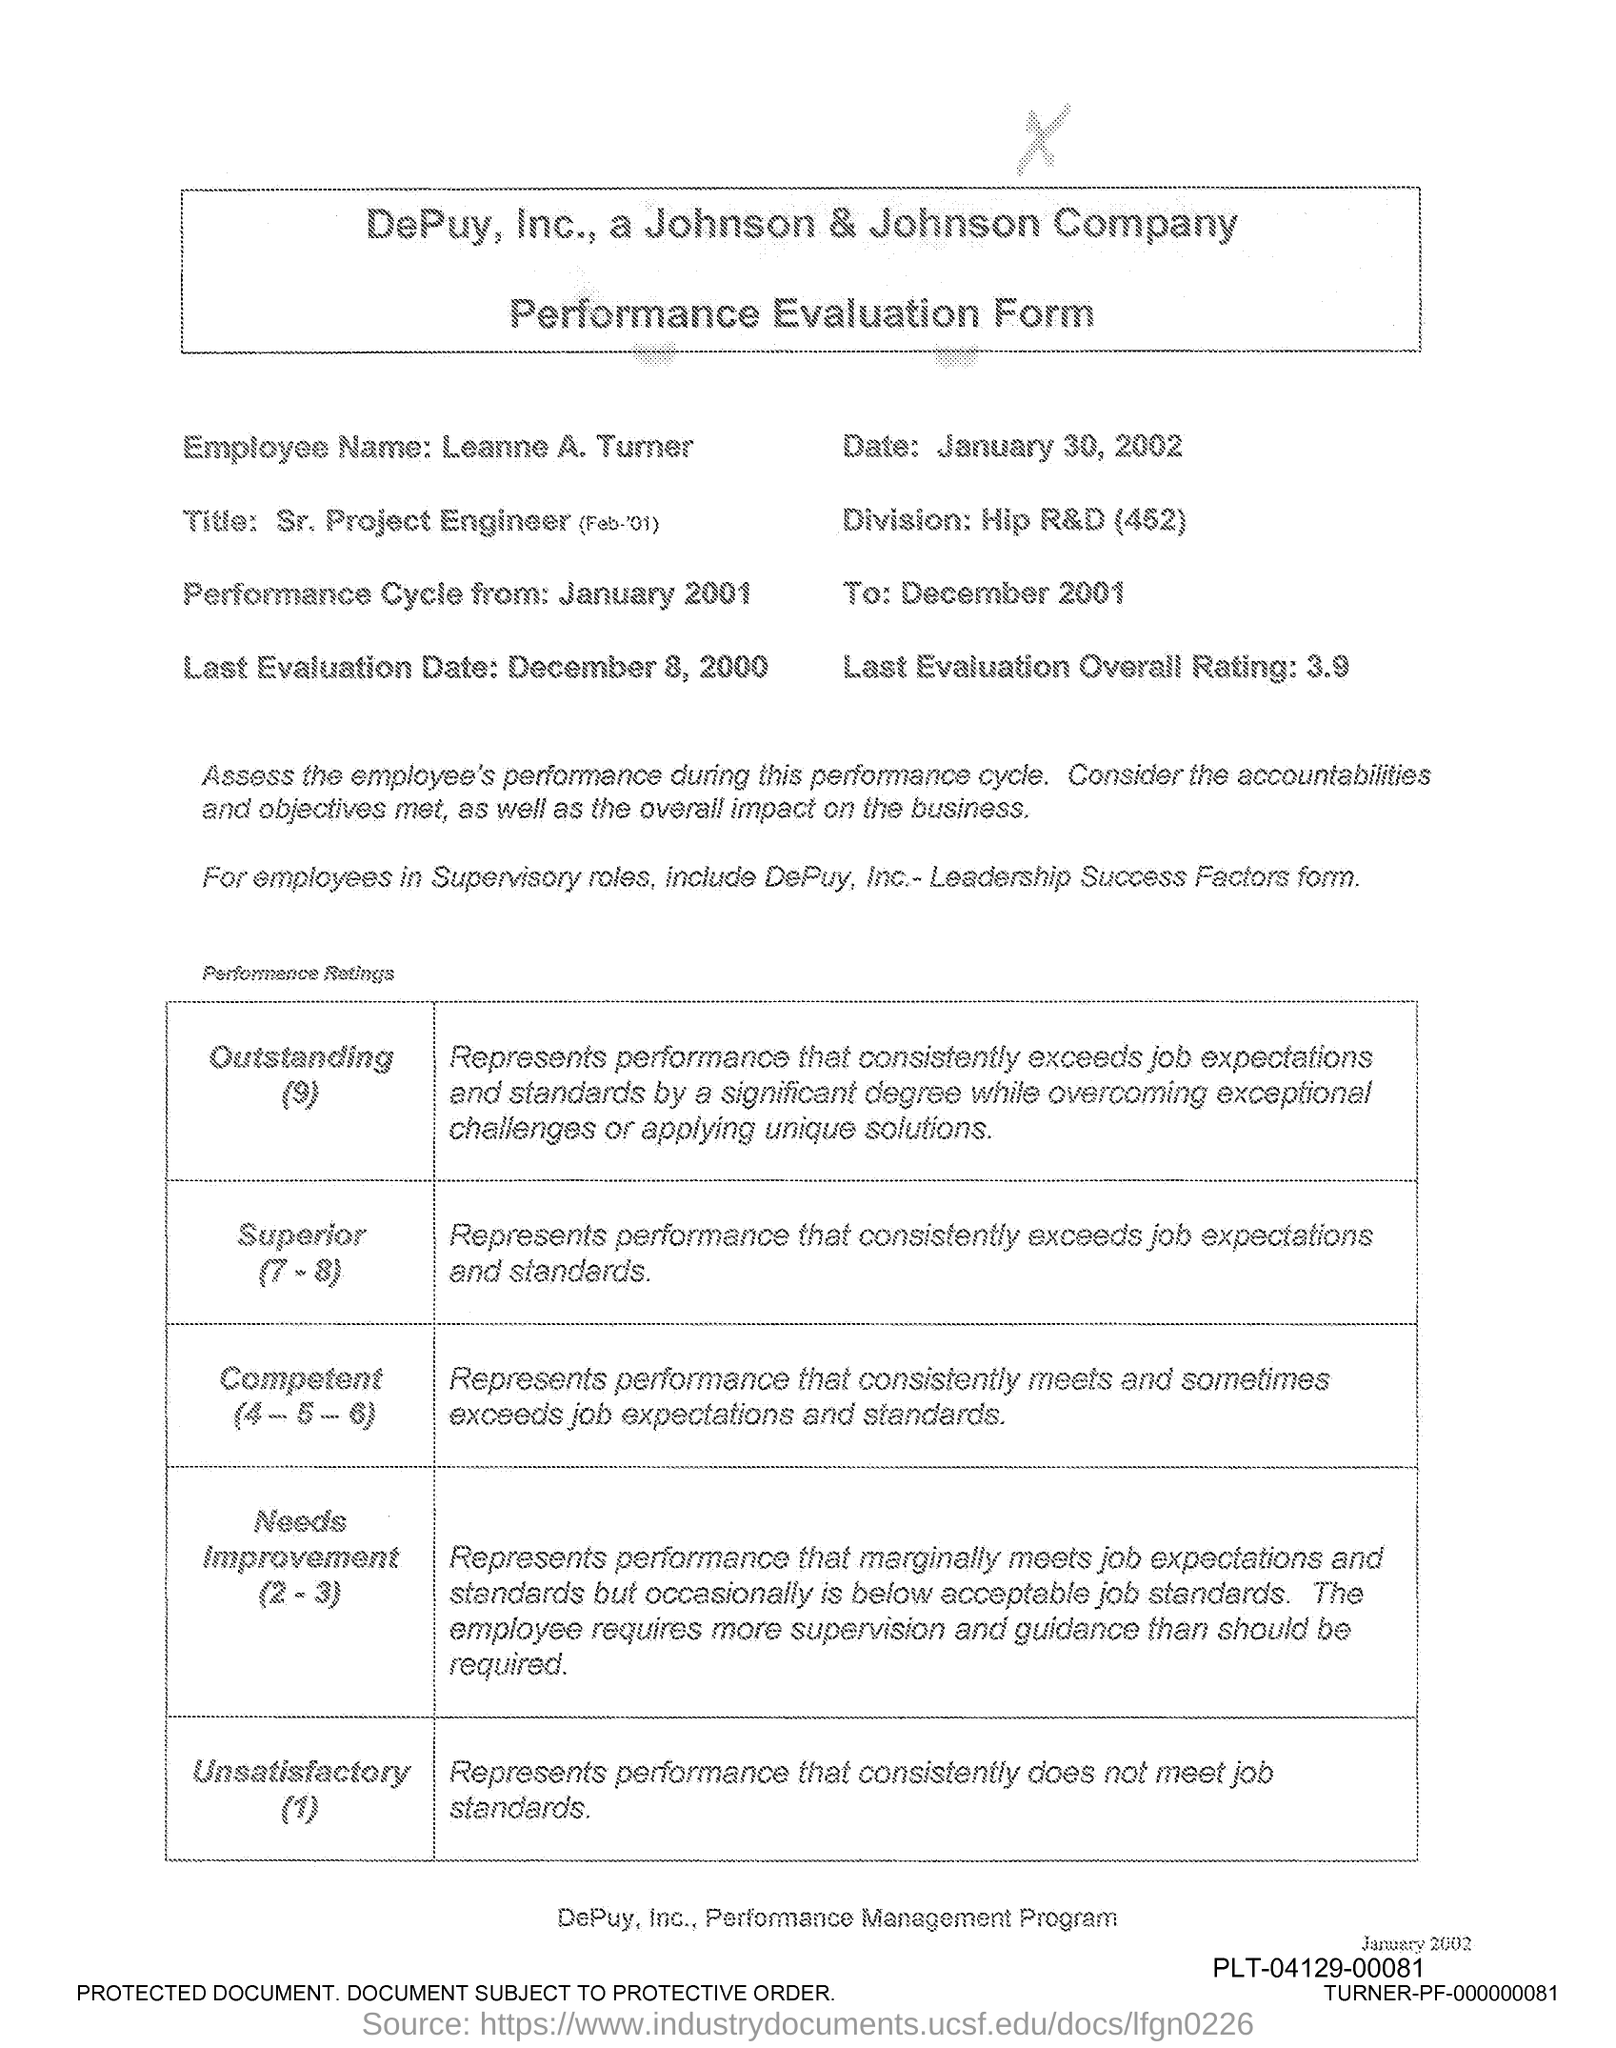Mention a couple of crucial points in this snapshot. The Division is a product created by Hip R&D with a focus on research and development, specifically designed for the purpose of [insert purpose here]. The overall rating for the last evaluation is 3.9. The last evaluation date was December 8, 2000. The date is January 30, 2002. The Employee Name is Leanne A. Turner. 